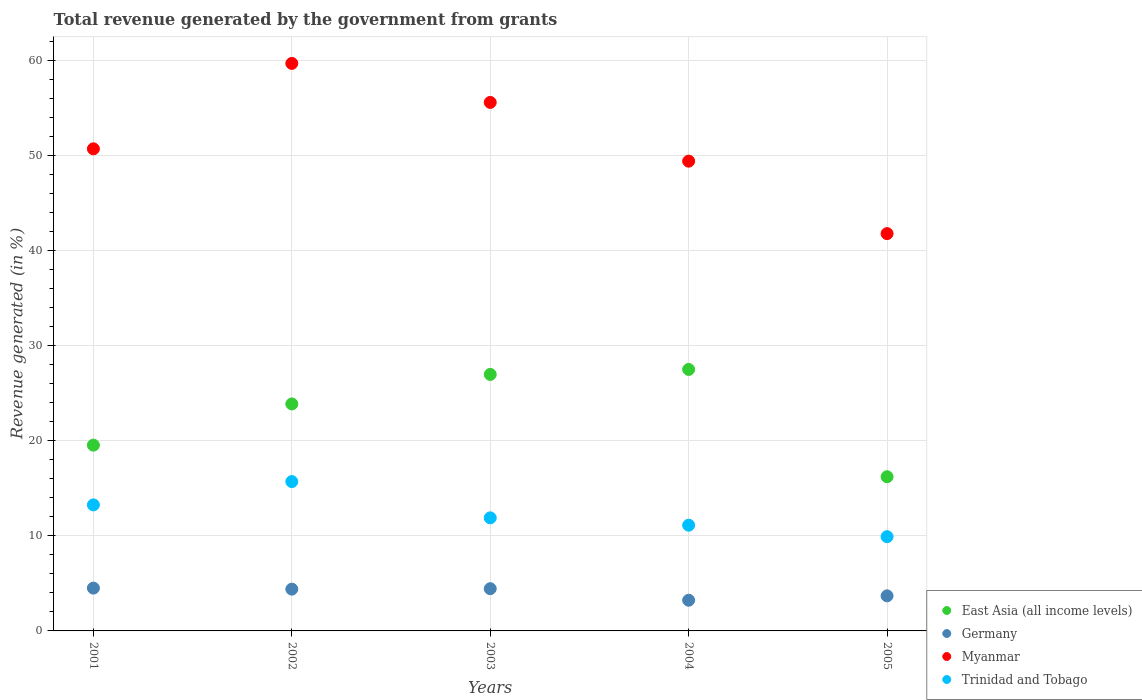What is the total revenue generated in Germany in 2004?
Offer a terse response. 3.23. Across all years, what is the maximum total revenue generated in Trinidad and Tobago?
Give a very brief answer. 15.71. Across all years, what is the minimum total revenue generated in Trinidad and Tobago?
Offer a terse response. 9.91. What is the total total revenue generated in Myanmar in the graph?
Provide a short and direct response. 257.27. What is the difference between the total revenue generated in Trinidad and Tobago in 2004 and that in 2005?
Provide a short and direct response. 1.21. What is the difference between the total revenue generated in Trinidad and Tobago in 2002 and the total revenue generated in Germany in 2005?
Give a very brief answer. 12.02. What is the average total revenue generated in Germany per year?
Your answer should be very brief. 4.05. In the year 2002, what is the difference between the total revenue generated in East Asia (all income levels) and total revenue generated in Germany?
Offer a terse response. 19.48. What is the ratio of the total revenue generated in Myanmar in 2001 to that in 2004?
Make the answer very short. 1.03. Is the total revenue generated in Myanmar in 2002 less than that in 2004?
Ensure brevity in your answer.  No. Is the difference between the total revenue generated in East Asia (all income levels) in 2003 and 2005 greater than the difference between the total revenue generated in Germany in 2003 and 2005?
Provide a short and direct response. Yes. What is the difference between the highest and the second highest total revenue generated in East Asia (all income levels)?
Your response must be concise. 0.52. What is the difference between the highest and the lowest total revenue generated in East Asia (all income levels)?
Give a very brief answer. 11.29. Is it the case that in every year, the sum of the total revenue generated in Germany and total revenue generated in Myanmar  is greater than the total revenue generated in Trinidad and Tobago?
Make the answer very short. Yes. Is the total revenue generated in East Asia (all income levels) strictly greater than the total revenue generated in Trinidad and Tobago over the years?
Ensure brevity in your answer.  Yes. How many years are there in the graph?
Offer a very short reply. 5. What is the difference between two consecutive major ticks on the Y-axis?
Provide a succinct answer. 10. Are the values on the major ticks of Y-axis written in scientific E-notation?
Offer a terse response. No. Where does the legend appear in the graph?
Provide a succinct answer. Bottom right. How many legend labels are there?
Make the answer very short. 4. What is the title of the graph?
Provide a succinct answer. Total revenue generated by the government from grants. Does "Barbados" appear as one of the legend labels in the graph?
Offer a terse response. No. What is the label or title of the Y-axis?
Keep it short and to the point. Revenue generated (in %). What is the Revenue generated (in %) of East Asia (all income levels) in 2001?
Your answer should be compact. 19.55. What is the Revenue generated (in %) of Germany in 2001?
Provide a short and direct response. 4.51. What is the Revenue generated (in %) in Myanmar in 2001?
Your response must be concise. 50.72. What is the Revenue generated (in %) in Trinidad and Tobago in 2001?
Your answer should be very brief. 13.26. What is the Revenue generated (in %) of East Asia (all income levels) in 2002?
Ensure brevity in your answer.  23.88. What is the Revenue generated (in %) in Germany in 2002?
Provide a short and direct response. 4.4. What is the Revenue generated (in %) of Myanmar in 2002?
Provide a succinct answer. 59.71. What is the Revenue generated (in %) in Trinidad and Tobago in 2002?
Ensure brevity in your answer.  15.71. What is the Revenue generated (in %) of East Asia (all income levels) in 2003?
Your answer should be very brief. 26.99. What is the Revenue generated (in %) of Germany in 2003?
Your answer should be very brief. 4.44. What is the Revenue generated (in %) of Myanmar in 2003?
Give a very brief answer. 55.61. What is the Revenue generated (in %) of Trinidad and Tobago in 2003?
Provide a succinct answer. 11.9. What is the Revenue generated (in %) of East Asia (all income levels) in 2004?
Offer a terse response. 27.51. What is the Revenue generated (in %) of Germany in 2004?
Give a very brief answer. 3.23. What is the Revenue generated (in %) in Myanmar in 2004?
Offer a terse response. 49.43. What is the Revenue generated (in %) of Trinidad and Tobago in 2004?
Your response must be concise. 11.12. What is the Revenue generated (in %) in East Asia (all income levels) in 2005?
Your response must be concise. 16.22. What is the Revenue generated (in %) of Germany in 2005?
Ensure brevity in your answer.  3.69. What is the Revenue generated (in %) of Myanmar in 2005?
Provide a succinct answer. 41.8. What is the Revenue generated (in %) of Trinidad and Tobago in 2005?
Your response must be concise. 9.91. Across all years, what is the maximum Revenue generated (in %) in East Asia (all income levels)?
Provide a short and direct response. 27.51. Across all years, what is the maximum Revenue generated (in %) of Germany?
Your response must be concise. 4.51. Across all years, what is the maximum Revenue generated (in %) in Myanmar?
Provide a short and direct response. 59.71. Across all years, what is the maximum Revenue generated (in %) of Trinidad and Tobago?
Your response must be concise. 15.71. Across all years, what is the minimum Revenue generated (in %) in East Asia (all income levels)?
Make the answer very short. 16.22. Across all years, what is the minimum Revenue generated (in %) of Germany?
Your response must be concise. 3.23. Across all years, what is the minimum Revenue generated (in %) of Myanmar?
Ensure brevity in your answer.  41.8. Across all years, what is the minimum Revenue generated (in %) of Trinidad and Tobago?
Give a very brief answer. 9.91. What is the total Revenue generated (in %) of East Asia (all income levels) in the graph?
Your answer should be compact. 114.15. What is the total Revenue generated (in %) of Germany in the graph?
Your response must be concise. 20.27. What is the total Revenue generated (in %) of Myanmar in the graph?
Provide a short and direct response. 257.27. What is the total Revenue generated (in %) in Trinidad and Tobago in the graph?
Give a very brief answer. 61.91. What is the difference between the Revenue generated (in %) of East Asia (all income levels) in 2001 and that in 2002?
Give a very brief answer. -4.34. What is the difference between the Revenue generated (in %) of Germany in 2001 and that in 2002?
Make the answer very short. 0.11. What is the difference between the Revenue generated (in %) in Myanmar in 2001 and that in 2002?
Give a very brief answer. -8.99. What is the difference between the Revenue generated (in %) of Trinidad and Tobago in 2001 and that in 2002?
Offer a very short reply. -2.45. What is the difference between the Revenue generated (in %) of East Asia (all income levels) in 2001 and that in 2003?
Your answer should be compact. -7.44. What is the difference between the Revenue generated (in %) in Germany in 2001 and that in 2003?
Your answer should be very brief. 0.06. What is the difference between the Revenue generated (in %) of Myanmar in 2001 and that in 2003?
Your answer should be compact. -4.88. What is the difference between the Revenue generated (in %) of Trinidad and Tobago in 2001 and that in 2003?
Your response must be concise. 1.36. What is the difference between the Revenue generated (in %) of East Asia (all income levels) in 2001 and that in 2004?
Your answer should be compact. -7.97. What is the difference between the Revenue generated (in %) in Germany in 2001 and that in 2004?
Ensure brevity in your answer.  1.28. What is the difference between the Revenue generated (in %) of Myanmar in 2001 and that in 2004?
Your answer should be compact. 1.3. What is the difference between the Revenue generated (in %) of Trinidad and Tobago in 2001 and that in 2004?
Provide a short and direct response. 2.14. What is the difference between the Revenue generated (in %) in East Asia (all income levels) in 2001 and that in 2005?
Your answer should be compact. 3.32. What is the difference between the Revenue generated (in %) in Germany in 2001 and that in 2005?
Ensure brevity in your answer.  0.82. What is the difference between the Revenue generated (in %) of Myanmar in 2001 and that in 2005?
Your response must be concise. 8.92. What is the difference between the Revenue generated (in %) of Trinidad and Tobago in 2001 and that in 2005?
Your response must be concise. 3.35. What is the difference between the Revenue generated (in %) of East Asia (all income levels) in 2002 and that in 2003?
Keep it short and to the point. -3.11. What is the difference between the Revenue generated (in %) of Germany in 2002 and that in 2003?
Your answer should be very brief. -0.05. What is the difference between the Revenue generated (in %) of Myanmar in 2002 and that in 2003?
Provide a succinct answer. 4.1. What is the difference between the Revenue generated (in %) in Trinidad and Tobago in 2002 and that in 2003?
Give a very brief answer. 3.81. What is the difference between the Revenue generated (in %) of East Asia (all income levels) in 2002 and that in 2004?
Give a very brief answer. -3.63. What is the difference between the Revenue generated (in %) of Germany in 2002 and that in 2004?
Your answer should be very brief. 1.17. What is the difference between the Revenue generated (in %) in Myanmar in 2002 and that in 2004?
Keep it short and to the point. 10.28. What is the difference between the Revenue generated (in %) of Trinidad and Tobago in 2002 and that in 2004?
Offer a very short reply. 4.59. What is the difference between the Revenue generated (in %) in East Asia (all income levels) in 2002 and that in 2005?
Make the answer very short. 7.66. What is the difference between the Revenue generated (in %) of Germany in 2002 and that in 2005?
Offer a very short reply. 0.71. What is the difference between the Revenue generated (in %) in Myanmar in 2002 and that in 2005?
Give a very brief answer. 17.91. What is the difference between the Revenue generated (in %) in Trinidad and Tobago in 2002 and that in 2005?
Provide a short and direct response. 5.8. What is the difference between the Revenue generated (in %) of East Asia (all income levels) in 2003 and that in 2004?
Offer a terse response. -0.52. What is the difference between the Revenue generated (in %) of Germany in 2003 and that in 2004?
Ensure brevity in your answer.  1.22. What is the difference between the Revenue generated (in %) in Myanmar in 2003 and that in 2004?
Provide a succinct answer. 6.18. What is the difference between the Revenue generated (in %) of Trinidad and Tobago in 2003 and that in 2004?
Offer a terse response. 0.77. What is the difference between the Revenue generated (in %) in East Asia (all income levels) in 2003 and that in 2005?
Make the answer very short. 10.77. What is the difference between the Revenue generated (in %) of Germany in 2003 and that in 2005?
Your response must be concise. 0.75. What is the difference between the Revenue generated (in %) of Myanmar in 2003 and that in 2005?
Your answer should be very brief. 13.8. What is the difference between the Revenue generated (in %) of Trinidad and Tobago in 2003 and that in 2005?
Provide a short and direct response. 1.98. What is the difference between the Revenue generated (in %) of East Asia (all income levels) in 2004 and that in 2005?
Make the answer very short. 11.29. What is the difference between the Revenue generated (in %) of Germany in 2004 and that in 2005?
Provide a succinct answer. -0.46. What is the difference between the Revenue generated (in %) of Myanmar in 2004 and that in 2005?
Your answer should be very brief. 7.62. What is the difference between the Revenue generated (in %) of Trinidad and Tobago in 2004 and that in 2005?
Provide a short and direct response. 1.21. What is the difference between the Revenue generated (in %) of East Asia (all income levels) in 2001 and the Revenue generated (in %) of Germany in 2002?
Give a very brief answer. 15.15. What is the difference between the Revenue generated (in %) of East Asia (all income levels) in 2001 and the Revenue generated (in %) of Myanmar in 2002?
Your response must be concise. -40.16. What is the difference between the Revenue generated (in %) of East Asia (all income levels) in 2001 and the Revenue generated (in %) of Trinidad and Tobago in 2002?
Make the answer very short. 3.83. What is the difference between the Revenue generated (in %) in Germany in 2001 and the Revenue generated (in %) in Myanmar in 2002?
Offer a very short reply. -55.2. What is the difference between the Revenue generated (in %) in Germany in 2001 and the Revenue generated (in %) in Trinidad and Tobago in 2002?
Offer a very short reply. -11.21. What is the difference between the Revenue generated (in %) in Myanmar in 2001 and the Revenue generated (in %) in Trinidad and Tobago in 2002?
Make the answer very short. 35.01. What is the difference between the Revenue generated (in %) of East Asia (all income levels) in 2001 and the Revenue generated (in %) of Germany in 2003?
Provide a succinct answer. 15.1. What is the difference between the Revenue generated (in %) of East Asia (all income levels) in 2001 and the Revenue generated (in %) of Myanmar in 2003?
Make the answer very short. -36.06. What is the difference between the Revenue generated (in %) of East Asia (all income levels) in 2001 and the Revenue generated (in %) of Trinidad and Tobago in 2003?
Ensure brevity in your answer.  7.65. What is the difference between the Revenue generated (in %) of Germany in 2001 and the Revenue generated (in %) of Myanmar in 2003?
Make the answer very short. -51.1. What is the difference between the Revenue generated (in %) of Germany in 2001 and the Revenue generated (in %) of Trinidad and Tobago in 2003?
Your answer should be very brief. -7.39. What is the difference between the Revenue generated (in %) in Myanmar in 2001 and the Revenue generated (in %) in Trinidad and Tobago in 2003?
Provide a succinct answer. 38.82. What is the difference between the Revenue generated (in %) in East Asia (all income levels) in 2001 and the Revenue generated (in %) in Germany in 2004?
Your answer should be compact. 16.32. What is the difference between the Revenue generated (in %) of East Asia (all income levels) in 2001 and the Revenue generated (in %) of Myanmar in 2004?
Your answer should be compact. -29.88. What is the difference between the Revenue generated (in %) of East Asia (all income levels) in 2001 and the Revenue generated (in %) of Trinidad and Tobago in 2004?
Make the answer very short. 8.42. What is the difference between the Revenue generated (in %) in Germany in 2001 and the Revenue generated (in %) in Myanmar in 2004?
Make the answer very short. -44.92. What is the difference between the Revenue generated (in %) in Germany in 2001 and the Revenue generated (in %) in Trinidad and Tobago in 2004?
Offer a terse response. -6.62. What is the difference between the Revenue generated (in %) in Myanmar in 2001 and the Revenue generated (in %) in Trinidad and Tobago in 2004?
Your response must be concise. 39.6. What is the difference between the Revenue generated (in %) in East Asia (all income levels) in 2001 and the Revenue generated (in %) in Germany in 2005?
Keep it short and to the point. 15.86. What is the difference between the Revenue generated (in %) in East Asia (all income levels) in 2001 and the Revenue generated (in %) in Myanmar in 2005?
Keep it short and to the point. -22.26. What is the difference between the Revenue generated (in %) of East Asia (all income levels) in 2001 and the Revenue generated (in %) of Trinidad and Tobago in 2005?
Offer a terse response. 9.63. What is the difference between the Revenue generated (in %) in Germany in 2001 and the Revenue generated (in %) in Myanmar in 2005?
Your answer should be very brief. -37.3. What is the difference between the Revenue generated (in %) in Germany in 2001 and the Revenue generated (in %) in Trinidad and Tobago in 2005?
Your response must be concise. -5.41. What is the difference between the Revenue generated (in %) in Myanmar in 2001 and the Revenue generated (in %) in Trinidad and Tobago in 2005?
Your response must be concise. 40.81. What is the difference between the Revenue generated (in %) in East Asia (all income levels) in 2002 and the Revenue generated (in %) in Germany in 2003?
Offer a very short reply. 19.44. What is the difference between the Revenue generated (in %) in East Asia (all income levels) in 2002 and the Revenue generated (in %) in Myanmar in 2003?
Offer a very short reply. -31.72. What is the difference between the Revenue generated (in %) in East Asia (all income levels) in 2002 and the Revenue generated (in %) in Trinidad and Tobago in 2003?
Make the answer very short. 11.98. What is the difference between the Revenue generated (in %) of Germany in 2002 and the Revenue generated (in %) of Myanmar in 2003?
Your answer should be very brief. -51.21. What is the difference between the Revenue generated (in %) in Germany in 2002 and the Revenue generated (in %) in Trinidad and Tobago in 2003?
Provide a short and direct response. -7.5. What is the difference between the Revenue generated (in %) of Myanmar in 2002 and the Revenue generated (in %) of Trinidad and Tobago in 2003?
Your answer should be compact. 47.81. What is the difference between the Revenue generated (in %) in East Asia (all income levels) in 2002 and the Revenue generated (in %) in Germany in 2004?
Offer a very short reply. 20.65. What is the difference between the Revenue generated (in %) of East Asia (all income levels) in 2002 and the Revenue generated (in %) of Myanmar in 2004?
Offer a terse response. -25.54. What is the difference between the Revenue generated (in %) in East Asia (all income levels) in 2002 and the Revenue generated (in %) in Trinidad and Tobago in 2004?
Make the answer very short. 12.76. What is the difference between the Revenue generated (in %) in Germany in 2002 and the Revenue generated (in %) in Myanmar in 2004?
Provide a succinct answer. -45.03. What is the difference between the Revenue generated (in %) of Germany in 2002 and the Revenue generated (in %) of Trinidad and Tobago in 2004?
Provide a succinct answer. -6.73. What is the difference between the Revenue generated (in %) of Myanmar in 2002 and the Revenue generated (in %) of Trinidad and Tobago in 2004?
Make the answer very short. 48.59. What is the difference between the Revenue generated (in %) in East Asia (all income levels) in 2002 and the Revenue generated (in %) in Germany in 2005?
Your answer should be compact. 20.19. What is the difference between the Revenue generated (in %) of East Asia (all income levels) in 2002 and the Revenue generated (in %) of Myanmar in 2005?
Offer a terse response. -17.92. What is the difference between the Revenue generated (in %) in East Asia (all income levels) in 2002 and the Revenue generated (in %) in Trinidad and Tobago in 2005?
Your response must be concise. 13.97. What is the difference between the Revenue generated (in %) of Germany in 2002 and the Revenue generated (in %) of Myanmar in 2005?
Your answer should be very brief. -37.41. What is the difference between the Revenue generated (in %) in Germany in 2002 and the Revenue generated (in %) in Trinidad and Tobago in 2005?
Offer a very short reply. -5.52. What is the difference between the Revenue generated (in %) of Myanmar in 2002 and the Revenue generated (in %) of Trinidad and Tobago in 2005?
Give a very brief answer. 49.79. What is the difference between the Revenue generated (in %) of East Asia (all income levels) in 2003 and the Revenue generated (in %) of Germany in 2004?
Keep it short and to the point. 23.76. What is the difference between the Revenue generated (in %) of East Asia (all income levels) in 2003 and the Revenue generated (in %) of Myanmar in 2004?
Provide a succinct answer. -22.44. What is the difference between the Revenue generated (in %) in East Asia (all income levels) in 2003 and the Revenue generated (in %) in Trinidad and Tobago in 2004?
Offer a very short reply. 15.86. What is the difference between the Revenue generated (in %) of Germany in 2003 and the Revenue generated (in %) of Myanmar in 2004?
Provide a short and direct response. -44.98. What is the difference between the Revenue generated (in %) of Germany in 2003 and the Revenue generated (in %) of Trinidad and Tobago in 2004?
Your answer should be compact. -6.68. What is the difference between the Revenue generated (in %) in Myanmar in 2003 and the Revenue generated (in %) in Trinidad and Tobago in 2004?
Provide a succinct answer. 44.48. What is the difference between the Revenue generated (in %) in East Asia (all income levels) in 2003 and the Revenue generated (in %) in Germany in 2005?
Provide a short and direct response. 23.3. What is the difference between the Revenue generated (in %) in East Asia (all income levels) in 2003 and the Revenue generated (in %) in Myanmar in 2005?
Provide a short and direct response. -14.81. What is the difference between the Revenue generated (in %) of East Asia (all income levels) in 2003 and the Revenue generated (in %) of Trinidad and Tobago in 2005?
Your answer should be very brief. 17.07. What is the difference between the Revenue generated (in %) in Germany in 2003 and the Revenue generated (in %) in Myanmar in 2005?
Offer a very short reply. -37.36. What is the difference between the Revenue generated (in %) in Germany in 2003 and the Revenue generated (in %) in Trinidad and Tobago in 2005?
Your response must be concise. -5.47. What is the difference between the Revenue generated (in %) of Myanmar in 2003 and the Revenue generated (in %) of Trinidad and Tobago in 2005?
Your response must be concise. 45.69. What is the difference between the Revenue generated (in %) of East Asia (all income levels) in 2004 and the Revenue generated (in %) of Germany in 2005?
Your answer should be compact. 23.82. What is the difference between the Revenue generated (in %) in East Asia (all income levels) in 2004 and the Revenue generated (in %) in Myanmar in 2005?
Keep it short and to the point. -14.29. What is the difference between the Revenue generated (in %) in East Asia (all income levels) in 2004 and the Revenue generated (in %) in Trinidad and Tobago in 2005?
Provide a succinct answer. 17.6. What is the difference between the Revenue generated (in %) of Germany in 2004 and the Revenue generated (in %) of Myanmar in 2005?
Your answer should be compact. -38.57. What is the difference between the Revenue generated (in %) in Germany in 2004 and the Revenue generated (in %) in Trinidad and Tobago in 2005?
Offer a very short reply. -6.69. What is the difference between the Revenue generated (in %) in Myanmar in 2004 and the Revenue generated (in %) in Trinidad and Tobago in 2005?
Your answer should be compact. 39.51. What is the average Revenue generated (in %) of East Asia (all income levels) per year?
Provide a short and direct response. 22.83. What is the average Revenue generated (in %) of Germany per year?
Ensure brevity in your answer.  4.05. What is the average Revenue generated (in %) of Myanmar per year?
Make the answer very short. 51.45. What is the average Revenue generated (in %) in Trinidad and Tobago per year?
Give a very brief answer. 12.38. In the year 2001, what is the difference between the Revenue generated (in %) of East Asia (all income levels) and Revenue generated (in %) of Germany?
Ensure brevity in your answer.  15.04. In the year 2001, what is the difference between the Revenue generated (in %) in East Asia (all income levels) and Revenue generated (in %) in Myanmar?
Keep it short and to the point. -31.18. In the year 2001, what is the difference between the Revenue generated (in %) of East Asia (all income levels) and Revenue generated (in %) of Trinidad and Tobago?
Your answer should be very brief. 6.29. In the year 2001, what is the difference between the Revenue generated (in %) of Germany and Revenue generated (in %) of Myanmar?
Provide a succinct answer. -46.22. In the year 2001, what is the difference between the Revenue generated (in %) of Germany and Revenue generated (in %) of Trinidad and Tobago?
Give a very brief answer. -8.75. In the year 2001, what is the difference between the Revenue generated (in %) in Myanmar and Revenue generated (in %) in Trinidad and Tobago?
Ensure brevity in your answer.  37.46. In the year 2002, what is the difference between the Revenue generated (in %) in East Asia (all income levels) and Revenue generated (in %) in Germany?
Give a very brief answer. 19.48. In the year 2002, what is the difference between the Revenue generated (in %) of East Asia (all income levels) and Revenue generated (in %) of Myanmar?
Offer a terse response. -35.83. In the year 2002, what is the difference between the Revenue generated (in %) in East Asia (all income levels) and Revenue generated (in %) in Trinidad and Tobago?
Offer a terse response. 8.17. In the year 2002, what is the difference between the Revenue generated (in %) of Germany and Revenue generated (in %) of Myanmar?
Make the answer very short. -55.31. In the year 2002, what is the difference between the Revenue generated (in %) in Germany and Revenue generated (in %) in Trinidad and Tobago?
Provide a succinct answer. -11.32. In the year 2002, what is the difference between the Revenue generated (in %) of Myanmar and Revenue generated (in %) of Trinidad and Tobago?
Keep it short and to the point. 44. In the year 2003, what is the difference between the Revenue generated (in %) of East Asia (all income levels) and Revenue generated (in %) of Germany?
Offer a terse response. 22.54. In the year 2003, what is the difference between the Revenue generated (in %) in East Asia (all income levels) and Revenue generated (in %) in Myanmar?
Provide a short and direct response. -28.62. In the year 2003, what is the difference between the Revenue generated (in %) of East Asia (all income levels) and Revenue generated (in %) of Trinidad and Tobago?
Provide a succinct answer. 15.09. In the year 2003, what is the difference between the Revenue generated (in %) in Germany and Revenue generated (in %) in Myanmar?
Offer a terse response. -51.16. In the year 2003, what is the difference between the Revenue generated (in %) in Germany and Revenue generated (in %) in Trinidad and Tobago?
Keep it short and to the point. -7.45. In the year 2003, what is the difference between the Revenue generated (in %) in Myanmar and Revenue generated (in %) in Trinidad and Tobago?
Your answer should be very brief. 43.71. In the year 2004, what is the difference between the Revenue generated (in %) in East Asia (all income levels) and Revenue generated (in %) in Germany?
Provide a short and direct response. 24.28. In the year 2004, what is the difference between the Revenue generated (in %) of East Asia (all income levels) and Revenue generated (in %) of Myanmar?
Give a very brief answer. -21.91. In the year 2004, what is the difference between the Revenue generated (in %) in East Asia (all income levels) and Revenue generated (in %) in Trinidad and Tobago?
Your answer should be very brief. 16.39. In the year 2004, what is the difference between the Revenue generated (in %) of Germany and Revenue generated (in %) of Myanmar?
Keep it short and to the point. -46.2. In the year 2004, what is the difference between the Revenue generated (in %) in Germany and Revenue generated (in %) in Trinidad and Tobago?
Offer a terse response. -7.89. In the year 2004, what is the difference between the Revenue generated (in %) of Myanmar and Revenue generated (in %) of Trinidad and Tobago?
Offer a very short reply. 38.3. In the year 2005, what is the difference between the Revenue generated (in %) of East Asia (all income levels) and Revenue generated (in %) of Germany?
Give a very brief answer. 12.53. In the year 2005, what is the difference between the Revenue generated (in %) of East Asia (all income levels) and Revenue generated (in %) of Myanmar?
Provide a succinct answer. -25.58. In the year 2005, what is the difference between the Revenue generated (in %) of East Asia (all income levels) and Revenue generated (in %) of Trinidad and Tobago?
Your answer should be very brief. 6.31. In the year 2005, what is the difference between the Revenue generated (in %) in Germany and Revenue generated (in %) in Myanmar?
Provide a succinct answer. -38.11. In the year 2005, what is the difference between the Revenue generated (in %) of Germany and Revenue generated (in %) of Trinidad and Tobago?
Give a very brief answer. -6.22. In the year 2005, what is the difference between the Revenue generated (in %) in Myanmar and Revenue generated (in %) in Trinidad and Tobago?
Ensure brevity in your answer.  31.89. What is the ratio of the Revenue generated (in %) of East Asia (all income levels) in 2001 to that in 2002?
Your answer should be very brief. 0.82. What is the ratio of the Revenue generated (in %) in Germany in 2001 to that in 2002?
Your answer should be compact. 1.02. What is the ratio of the Revenue generated (in %) in Myanmar in 2001 to that in 2002?
Your answer should be very brief. 0.85. What is the ratio of the Revenue generated (in %) of Trinidad and Tobago in 2001 to that in 2002?
Offer a very short reply. 0.84. What is the ratio of the Revenue generated (in %) in East Asia (all income levels) in 2001 to that in 2003?
Make the answer very short. 0.72. What is the ratio of the Revenue generated (in %) in Germany in 2001 to that in 2003?
Ensure brevity in your answer.  1.01. What is the ratio of the Revenue generated (in %) of Myanmar in 2001 to that in 2003?
Your answer should be compact. 0.91. What is the ratio of the Revenue generated (in %) of Trinidad and Tobago in 2001 to that in 2003?
Ensure brevity in your answer.  1.11. What is the ratio of the Revenue generated (in %) of East Asia (all income levels) in 2001 to that in 2004?
Keep it short and to the point. 0.71. What is the ratio of the Revenue generated (in %) of Germany in 2001 to that in 2004?
Make the answer very short. 1.4. What is the ratio of the Revenue generated (in %) of Myanmar in 2001 to that in 2004?
Your answer should be compact. 1.03. What is the ratio of the Revenue generated (in %) in Trinidad and Tobago in 2001 to that in 2004?
Provide a succinct answer. 1.19. What is the ratio of the Revenue generated (in %) in East Asia (all income levels) in 2001 to that in 2005?
Give a very brief answer. 1.2. What is the ratio of the Revenue generated (in %) of Germany in 2001 to that in 2005?
Your response must be concise. 1.22. What is the ratio of the Revenue generated (in %) of Myanmar in 2001 to that in 2005?
Offer a terse response. 1.21. What is the ratio of the Revenue generated (in %) of Trinidad and Tobago in 2001 to that in 2005?
Your answer should be very brief. 1.34. What is the ratio of the Revenue generated (in %) of East Asia (all income levels) in 2002 to that in 2003?
Your answer should be compact. 0.88. What is the ratio of the Revenue generated (in %) of Germany in 2002 to that in 2003?
Provide a short and direct response. 0.99. What is the ratio of the Revenue generated (in %) in Myanmar in 2002 to that in 2003?
Offer a very short reply. 1.07. What is the ratio of the Revenue generated (in %) of Trinidad and Tobago in 2002 to that in 2003?
Offer a very short reply. 1.32. What is the ratio of the Revenue generated (in %) in East Asia (all income levels) in 2002 to that in 2004?
Ensure brevity in your answer.  0.87. What is the ratio of the Revenue generated (in %) in Germany in 2002 to that in 2004?
Provide a succinct answer. 1.36. What is the ratio of the Revenue generated (in %) of Myanmar in 2002 to that in 2004?
Make the answer very short. 1.21. What is the ratio of the Revenue generated (in %) of Trinidad and Tobago in 2002 to that in 2004?
Make the answer very short. 1.41. What is the ratio of the Revenue generated (in %) in East Asia (all income levels) in 2002 to that in 2005?
Your answer should be compact. 1.47. What is the ratio of the Revenue generated (in %) of Germany in 2002 to that in 2005?
Your response must be concise. 1.19. What is the ratio of the Revenue generated (in %) in Myanmar in 2002 to that in 2005?
Your answer should be very brief. 1.43. What is the ratio of the Revenue generated (in %) in Trinidad and Tobago in 2002 to that in 2005?
Ensure brevity in your answer.  1.58. What is the ratio of the Revenue generated (in %) in East Asia (all income levels) in 2003 to that in 2004?
Give a very brief answer. 0.98. What is the ratio of the Revenue generated (in %) in Germany in 2003 to that in 2004?
Ensure brevity in your answer.  1.38. What is the ratio of the Revenue generated (in %) in Trinidad and Tobago in 2003 to that in 2004?
Make the answer very short. 1.07. What is the ratio of the Revenue generated (in %) of East Asia (all income levels) in 2003 to that in 2005?
Ensure brevity in your answer.  1.66. What is the ratio of the Revenue generated (in %) of Germany in 2003 to that in 2005?
Provide a succinct answer. 1.2. What is the ratio of the Revenue generated (in %) of Myanmar in 2003 to that in 2005?
Offer a terse response. 1.33. What is the ratio of the Revenue generated (in %) in Trinidad and Tobago in 2003 to that in 2005?
Provide a short and direct response. 1.2. What is the ratio of the Revenue generated (in %) in East Asia (all income levels) in 2004 to that in 2005?
Offer a terse response. 1.7. What is the ratio of the Revenue generated (in %) of Germany in 2004 to that in 2005?
Your answer should be very brief. 0.87. What is the ratio of the Revenue generated (in %) of Myanmar in 2004 to that in 2005?
Offer a terse response. 1.18. What is the ratio of the Revenue generated (in %) in Trinidad and Tobago in 2004 to that in 2005?
Provide a short and direct response. 1.12. What is the difference between the highest and the second highest Revenue generated (in %) in East Asia (all income levels)?
Your response must be concise. 0.52. What is the difference between the highest and the second highest Revenue generated (in %) in Germany?
Offer a very short reply. 0.06. What is the difference between the highest and the second highest Revenue generated (in %) of Myanmar?
Your answer should be compact. 4.1. What is the difference between the highest and the second highest Revenue generated (in %) of Trinidad and Tobago?
Make the answer very short. 2.45. What is the difference between the highest and the lowest Revenue generated (in %) of East Asia (all income levels)?
Your answer should be very brief. 11.29. What is the difference between the highest and the lowest Revenue generated (in %) in Germany?
Provide a short and direct response. 1.28. What is the difference between the highest and the lowest Revenue generated (in %) of Myanmar?
Your answer should be compact. 17.91. What is the difference between the highest and the lowest Revenue generated (in %) of Trinidad and Tobago?
Your response must be concise. 5.8. 